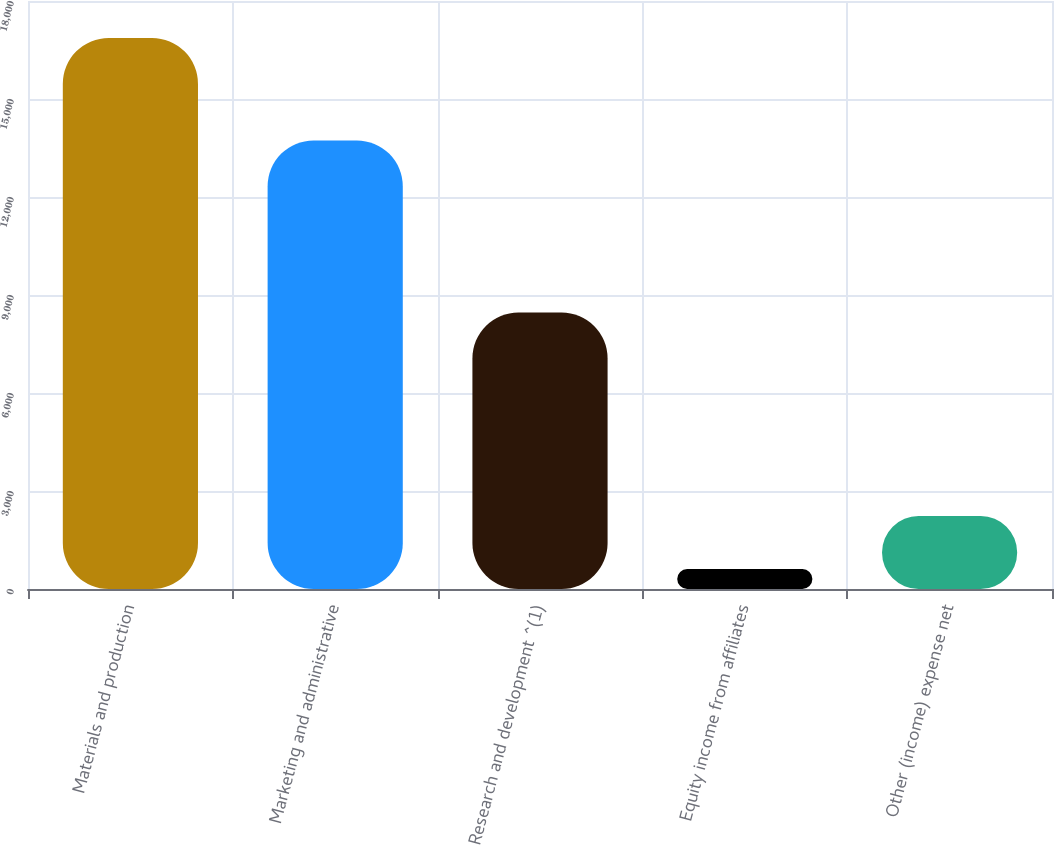Convert chart to OTSL. <chart><loc_0><loc_0><loc_500><loc_500><bar_chart><fcel>Materials and production<fcel>Marketing and administrative<fcel>Research and development ^(1)<fcel>Equity income from affiliates<fcel>Other (income) expense net<nl><fcel>16871<fcel>13733<fcel>8467<fcel>610<fcel>2236.1<nl></chart> 